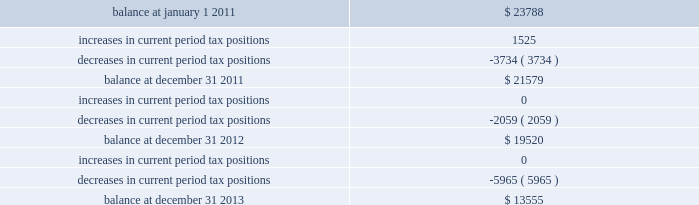The table summarizes the changes in the company 2019s valuation allowance: .
Included in 2013 is a discrete tax benefit totaling $ 2979 associated with an entity re-organization within the company 2019s market-based segment that allowed for the utilization of state net operating loss carryforwards and the release of an associated valuation allowance .
Note 14 : employee benefits pension and other postretirement benefits the company maintains noncontributory defined benefit pension plans covering eligible employees of its regulated utility and shared services operations .
Benefits under the plans are based on the employee 2019s years of service and compensation .
The pension plans have been closed for all employees .
The pension plans were closed for most employees hired on or after january 1 , 2006 .
Union employees hired on or after january 1 , 2001 had their accrued benefit frozen and will be able to receive this benefit as a lump sum upon termination or retirement .
Union employees hired on or after january 1 , 2001 and non-union employees hired on or after january 1 , 2006 are provided with a 5.25% ( 5.25 % ) of base pay defined contribution plan .
The company does not participate in a multiemployer plan .
The company 2019s pension funding practice is to contribute at least the greater of the minimum amount required by the employee retirement income security act of 1974 or the normal cost .
Further , the company will consider additional contributions if needed to avoid 201cat risk 201d status and benefit restrictions under the pension protection act of 2006 .
The company may also consider increased contributions , based on other financial requirements and the plans 2019 funded position .
Pension plan assets are invested in a number of actively managed and indexed investments including equity and bond mutual funds , fixed income securities , guaranteed interest contracts with insurance companies and real estate investment trusts ( 201creits 201d ) .
Pension expense in excess of the amount contributed to the pension plans is deferred by certain regulated subsidiaries pending future recovery in rates charged for utility services as contributions are made to the plans .
( see note 6 ) the company also has unfunded noncontributory supplemental non-qualified pension plans that provide additional retirement benefits to certain employees .
The company maintains other postretirement benefit plans providing varying levels of medical and life insurance to eligible retirees .
The retiree welfare plans are closed for union employees hired on or after january 1 , 2006 .
The plans had previously closed for non-union employees hired on or after january 1 , 2002 .
The company 2019s policy is to fund other postretirement benefit costs for rate-making purposes .
Assets of the plans are invested in equity mutual funds , bond mutual funds and fixed income securities. .
What is the company's net valuation allowance at the end of 2013? 
Rationale: in order to get the net valuation allowance you need to take out any special one time non-recurring revenues or expenses . since the discrete tax benefit is already included in the ending 2013 balance , you need to take it out to get to the net number
Computations: (13555 - 2979)
Answer: 10576.0. The table summarizes the changes in the company 2019s valuation allowance: .
Included in 2013 is a discrete tax benefit totaling $ 2979 associated with an entity re-organization within the company 2019s market-based segment that allowed for the utilization of state net operating loss carryforwards and the release of an associated valuation allowance .
Note 14 : employee benefits pension and other postretirement benefits the company maintains noncontributory defined benefit pension plans covering eligible employees of its regulated utility and shared services operations .
Benefits under the plans are based on the employee 2019s years of service and compensation .
The pension plans have been closed for all employees .
The pension plans were closed for most employees hired on or after january 1 , 2006 .
Union employees hired on or after january 1 , 2001 had their accrued benefit frozen and will be able to receive this benefit as a lump sum upon termination or retirement .
Union employees hired on or after january 1 , 2001 and non-union employees hired on or after january 1 , 2006 are provided with a 5.25% ( 5.25 % ) of base pay defined contribution plan .
The company does not participate in a multiemployer plan .
The company 2019s pension funding practice is to contribute at least the greater of the minimum amount required by the employee retirement income security act of 1974 or the normal cost .
Further , the company will consider additional contributions if needed to avoid 201cat risk 201d status and benefit restrictions under the pension protection act of 2006 .
The company may also consider increased contributions , based on other financial requirements and the plans 2019 funded position .
Pension plan assets are invested in a number of actively managed and indexed investments including equity and bond mutual funds , fixed income securities , guaranteed interest contracts with insurance companies and real estate investment trusts ( 201creits 201d ) .
Pension expense in excess of the amount contributed to the pension plans is deferred by certain regulated subsidiaries pending future recovery in rates charged for utility services as contributions are made to the plans .
( see note 6 ) the company also has unfunded noncontributory supplemental non-qualified pension plans that provide additional retirement benefits to certain employees .
The company maintains other postretirement benefit plans providing varying levels of medical and life insurance to eligible retirees .
The retiree welfare plans are closed for union employees hired on or after january 1 , 2006 .
The plans had previously closed for non-union employees hired on or after january 1 , 2002 .
The company 2019s policy is to fund other postretirement benefit costs for rate-making purposes .
Assets of the plans are invested in equity mutual funds , bond mutual funds and fixed income securities. .
What was the average decrease in the tax position from 2011 to 2013? 
Rationale: the average decrease over the 3 years is the sum of the decrease over the 3 years divide by 3
Computations: (((3734 + 2059) + 5965) / 3)
Answer: 3919.33333. 